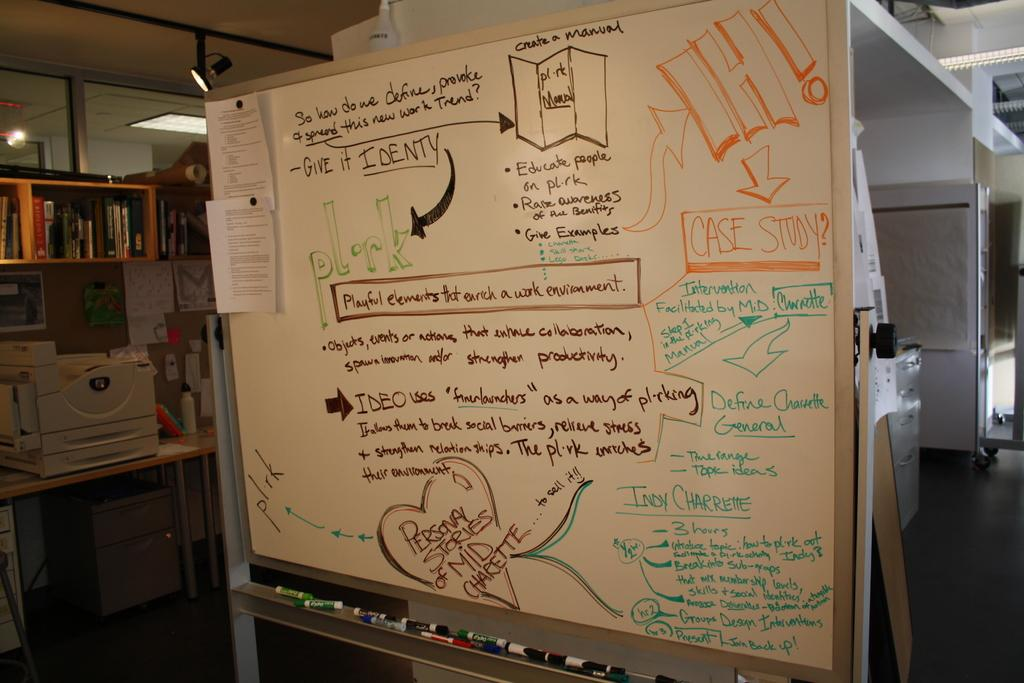<image>
Write a terse but informative summary of the picture. A white board inside a office area with different colored writing on it and a large IH! written followed by the words case study as there is a description 